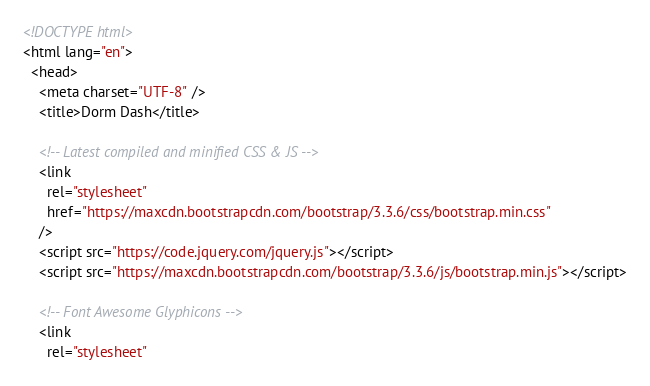<code> <loc_0><loc_0><loc_500><loc_500><_HTML_><!DOCTYPE html>
<html lang="en">
  <head>
    <meta charset="UTF-8" />
    <title>Dorm Dash</title>

    <!-- Latest compiled and minified CSS & JS -->
    <link
      rel="stylesheet"
      href="https://maxcdn.bootstrapcdn.com/bootstrap/3.3.6/css/bootstrap.min.css"
    />
    <script src="https://code.jquery.com/jquery.js"></script>
    <script src="https://maxcdn.bootstrapcdn.com/bootstrap/3.3.6/js/bootstrap.min.js"></script>

    <!-- Font Awesome Glyphicons -->
    <link
      rel="stylesheet"</code> 